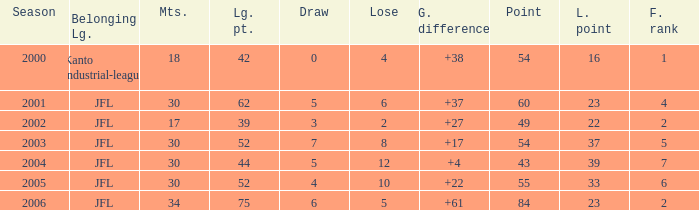Tell me the highest point with lost point being 33 and league point less than 52 None. 